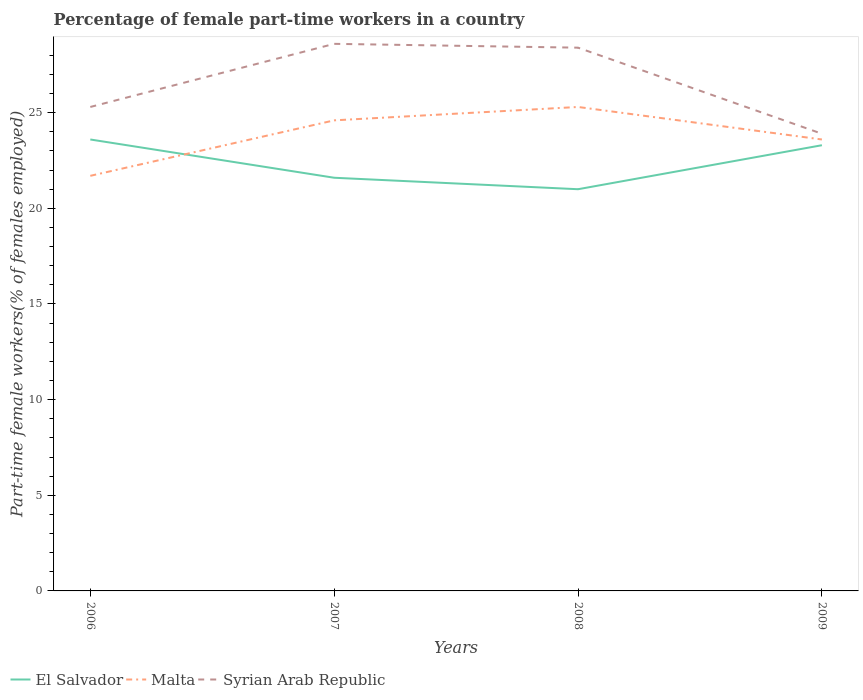Does the line corresponding to Malta intersect with the line corresponding to Syrian Arab Republic?
Keep it short and to the point. No. Across all years, what is the maximum percentage of female part-time workers in Syrian Arab Republic?
Provide a short and direct response. 23.9. What is the total percentage of female part-time workers in El Salvador in the graph?
Provide a succinct answer. 2. What is the difference between the highest and the second highest percentage of female part-time workers in Syrian Arab Republic?
Offer a very short reply. 4.7. What is the difference between the highest and the lowest percentage of female part-time workers in Malta?
Make the answer very short. 2. Is the percentage of female part-time workers in Malta strictly greater than the percentage of female part-time workers in Syrian Arab Republic over the years?
Your answer should be very brief. Yes. How many years are there in the graph?
Your response must be concise. 4. Are the values on the major ticks of Y-axis written in scientific E-notation?
Keep it short and to the point. No. Does the graph contain any zero values?
Give a very brief answer. No. Does the graph contain grids?
Your response must be concise. No. Where does the legend appear in the graph?
Your answer should be very brief. Bottom left. How many legend labels are there?
Offer a very short reply. 3. What is the title of the graph?
Provide a succinct answer. Percentage of female part-time workers in a country. What is the label or title of the Y-axis?
Make the answer very short. Part-time female workers(% of females employed). What is the Part-time female workers(% of females employed) of El Salvador in 2006?
Provide a short and direct response. 23.6. What is the Part-time female workers(% of females employed) of Malta in 2006?
Your answer should be very brief. 21.7. What is the Part-time female workers(% of females employed) in Syrian Arab Republic in 2006?
Your answer should be very brief. 25.3. What is the Part-time female workers(% of females employed) in El Salvador in 2007?
Your answer should be very brief. 21.6. What is the Part-time female workers(% of females employed) of Malta in 2007?
Provide a short and direct response. 24.6. What is the Part-time female workers(% of females employed) in Syrian Arab Republic in 2007?
Ensure brevity in your answer.  28.6. What is the Part-time female workers(% of females employed) in Malta in 2008?
Make the answer very short. 25.3. What is the Part-time female workers(% of females employed) of Syrian Arab Republic in 2008?
Give a very brief answer. 28.4. What is the Part-time female workers(% of females employed) in El Salvador in 2009?
Your response must be concise. 23.3. What is the Part-time female workers(% of females employed) of Malta in 2009?
Make the answer very short. 23.6. What is the Part-time female workers(% of females employed) of Syrian Arab Republic in 2009?
Provide a succinct answer. 23.9. Across all years, what is the maximum Part-time female workers(% of females employed) of El Salvador?
Offer a very short reply. 23.6. Across all years, what is the maximum Part-time female workers(% of females employed) of Malta?
Offer a terse response. 25.3. Across all years, what is the maximum Part-time female workers(% of females employed) of Syrian Arab Republic?
Your answer should be very brief. 28.6. Across all years, what is the minimum Part-time female workers(% of females employed) of Malta?
Ensure brevity in your answer.  21.7. Across all years, what is the minimum Part-time female workers(% of females employed) in Syrian Arab Republic?
Make the answer very short. 23.9. What is the total Part-time female workers(% of females employed) of El Salvador in the graph?
Provide a succinct answer. 89.5. What is the total Part-time female workers(% of females employed) in Malta in the graph?
Your answer should be very brief. 95.2. What is the total Part-time female workers(% of females employed) in Syrian Arab Republic in the graph?
Ensure brevity in your answer.  106.2. What is the difference between the Part-time female workers(% of females employed) in El Salvador in 2006 and that in 2007?
Offer a very short reply. 2. What is the difference between the Part-time female workers(% of females employed) in Syrian Arab Republic in 2006 and that in 2007?
Offer a terse response. -3.3. What is the difference between the Part-time female workers(% of females employed) of El Salvador in 2006 and that in 2008?
Provide a succinct answer. 2.6. What is the difference between the Part-time female workers(% of females employed) in Malta in 2006 and that in 2008?
Provide a short and direct response. -3.6. What is the difference between the Part-time female workers(% of females employed) of El Salvador in 2007 and that in 2008?
Give a very brief answer. 0.6. What is the difference between the Part-time female workers(% of females employed) of Malta in 2007 and that in 2008?
Keep it short and to the point. -0.7. What is the difference between the Part-time female workers(% of females employed) in Syrian Arab Republic in 2007 and that in 2008?
Make the answer very short. 0.2. What is the difference between the Part-time female workers(% of females employed) of Malta in 2007 and that in 2009?
Your response must be concise. 1. What is the difference between the Part-time female workers(% of females employed) of Syrian Arab Republic in 2007 and that in 2009?
Ensure brevity in your answer.  4.7. What is the difference between the Part-time female workers(% of females employed) in El Salvador in 2008 and that in 2009?
Keep it short and to the point. -2.3. What is the difference between the Part-time female workers(% of females employed) of Malta in 2008 and that in 2009?
Your response must be concise. 1.7. What is the difference between the Part-time female workers(% of females employed) in El Salvador in 2006 and the Part-time female workers(% of females employed) in Syrian Arab Republic in 2007?
Your answer should be very brief. -5. What is the difference between the Part-time female workers(% of females employed) in Malta in 2006 and the Part-time female workers(% of females employed) in Syrian Arab Republic in 2007?
Provide a short and direct response. -6.9. What is the difference between the Part-time female workers(% of females employed) in El Salvador in 2006 and the Part-time female workers(% of females employed) in Syrian Arab Republic in 2008?
Give a very brief answer. -4.8. What is the difference between the Part-time female workers(% of females employed) in Malta in 2006 and the Part-time female workers(% of females employed) in Syrian Arab Republic in 2008?
Your answer should be compact. -6.7. What is the difference between the Part-time female workers(% of females employed) of Malta in 2006 and the Part-time female workers(% of females employed) of Syrian Arab Republic in 2009?
Your answer should be very brief. -2.2. What is the difference between the Part-time female workers(% of females employed) in El Salvador in 2007 and the Part-time female workers(% of females employed) in Malta in 2009?
Keep it short and to the point. -2. What is the difference between the Part-time female workers(% of females employed) in Malta in 2007 and the Part-time female workers(% of females employed) in Syrian Arab Republic in 2009?
Keep it short and to the point. 0.7. What is the difference between the Part-time female workers(% of females employed) of El Salvador in 2008 and the Part-time female workers(% of females employed) of Malta in 2009?
Provide a succinct answer. -2.6. What is the difference between the Part-time female workers(% of females employed) of El Salvador in 2008 and the Part-time female workers(% of females employed) of Syrian Arab Republic in 2009?
Provide a short and direct response. -2.9. What is the difference between the Part-time female workers(% of females employed) in Malta in 2008 and the Part-time female workers(% of females employed) in Syrian Arab Republic in 2009?
Your response must be concise. 1.4. What is the average Part-time female workers(% of females employed) of El Salvador per year?
Provide a succinct answer. 22.38. What is the average Part-time female workers(% of females employed) of Malta per year?
Provide a succinct answer. 23.8. What is the average Part-time female workers(% of females employed) in Syrian Arab Republic per year?
Give a very brief answer. 26.55. In the year 2006, what is the difference between the Part-time female workers(% of females employed) of El Salvador and Part-time female workers(% of females employed) of Malta?
Provide a succinct answer. 1.9. In the year 2006, what is the difference between the Part-time female workers(% of females employed) of El Salvador and Part-time female workers(% of females employed) of Syrian Arab Republic?
Offer a very short reply. -1.7. In the year 2007, what is the difference between the Part-time female workers(% of females employed) of El Salvador and Part-time female workers(% of females employed) of Malta?
Your response must be concise. -3. In the year 2007, what is the difference between the Part-time female workers(% of females employed) in El Salvador and Part-time female workers(% of females employed) in Syrian Arab Republic?
Your answer should be compact. -7. In the year 2007, what is the difference between the Part-time female workers(% of females employed) of Malta and Part-time female workers(% of females employed) of Syrian Arab Republic?
Your answer should be very brief. -4. In the year 2008, what is the difference between the Part-time female workers(% of females employed) in El Salvador and Part-time female workers(% of females employed) in Malta?
Ensure brevity in your answer.  -4.3. In the year 2008, what is the difference between the Part-time female workers(% of females employed) of El Salvador and Part-time female workers(% of females employed) of Syrian Arab Republic?
Give a very brief answer. -7.4. In the year 2008, what is the difference between the Part-time female workers(% of females employed) of Malta and Part-time female workers(% of females employed) of Syrian Arab Republic?
Make the answer very short. -3.1. In the year 2009, what is the difference between the Part-time female workers(% of females employed) of Malta and Part-time female workers(% of females employed) of Syrian Arab Republic?
Provide a succinct answer. -0.3. What is the ratio of the Part-time female workers(% of females employed) of El Salvador in 2006 to that in 2007?
Make the answer very short. 1.09. What is the ratio of the Part-time female workers(% of females employed) of Malta in 2006 to that in 2007?
Keep it short and to the point. 0.88. What is the ratio of the Part-time female workers(% of females employed) in Syrian Arab Republic in 2006 to that in 2007?
Your answer should be compact. 0.88. What is the ratio of the Part-time female workers(% of females employed) of El Salvador in 2006 to that in 2008?
Make the answer very short. 1.12. What is the ratio of the Part-time female workers(% of females employed) in Malta in 2006 to that in 2008?
Keep it short and to the point. 0.86. What is the ratio of the Part-time female workers(% of females employed) in Syrian Arab Republic in 2006 to that in 2008?
Make the answer very short. 0.89. What is the ratio of the Part-time female workers(% of females employed) of El Salvador in 2006 to that in 2009?
Offer a terse response. 1.01. What is the ratio of the Part-time female workers(% of females employed) in Malta in 2006 to that in 2009?
Ensure brevity in your answer.  0.92. What is the ratio of the Part-time female workers(% of females employed) in Syrian Arab Republic in 2006 to that in 2009?
Ensure brevity in your answer.  1.06. What is the ratio of the Part-time female workers(% of females employed) of El Salvador in 2007 to that in 2008?
Provide a succinct answer. 1.03. What is the ratio of the Part-time female workers(% of females employed) in Malta in 2007 to that in 2008?
Your answer should be very brief. 0.97. What is the ratio of the Part-time female workers(% of females employed) of Syrian Arab Republic in 2007 to that in 2008?
Provide a short and direct response. 1.01. What is the ratio of the Part-time female workers(% of females employed) in El Salvador in 2007 to that in 2009?
Provide a short and direct response. 0.93. What is the ratio of the Part-time female workers(% of females employed) of Malta in 2007 to that in 2009?
Make the answer very short. 1.04. What is the ratio of the Part-time female workers(% of females employed) in Syrian Arab Republic in 2007 to that in 2009?
Offer a very short reply. 1.2. What is the ratio of the Part-time female workers(% of females employed) of El Salvador in 2008 to that in 2009?
Your answer should be very brief. 0.9. What is the ratio of the Part-time female workers(% of females employed) in Malta in 2008 to that in 2009?
Your answer should be very brief. 1.07. What is the ratio of the Part-time female workers(% of females employed) in Syrian Arab Republic in 2008 to that in 2009?
Offer a very short reply. 1.19. What is the difference between the highest and the second highest Part-time female workers(% of females employed) in El Salvador?
Your answer should be compact. 0.3. What is the difference between the highest and the second highest Part-time female workers(% of females employed) of Syrian Arab Republic?
Offer a terse response. 0.2. What is the difference between the highest and the lowest Part-time female workers(% of females employed) in El Salvador?
Offer a terse response. 2.6. What is the difference between the highest and the lowest Part-time female workers(% of females employed) in Malta?
Your response must be concise. 3.6. What is the difference between the highest and the lowest Part-time female workers(% of females employed) in Syrian Arab Republic?
Your response must be concise. 4.7. 